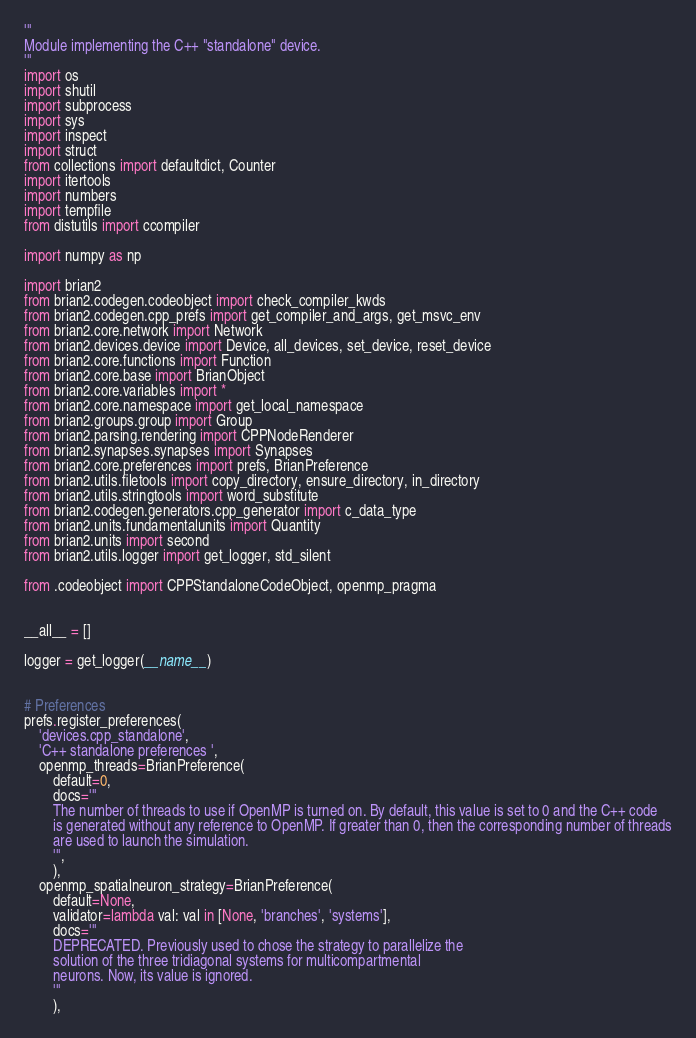<code> <loc_0><loc_0><loc_500><loc_500><_Python_>

'''
Module implementing the C++ "standalone" device.
'''
import os
import shutil
import subprocess
import sys
import inspect
import struct
from collections import defaultdict, Counter
import itertools
import numbers
import tempfile
from distutils import ccompiler

import numpy as np

import brian2
from brian2.codegen.codeobject import check_compiler_kwds
from brian2.codegen.cpp_prefs import get_compiler_and_args, get_msvc_env
from brian2.core.network import Network
from brian2.devices.device import Device, all_devices, set_device, reset_device
from brian2.core.functions import Function
from brian2.core.base import BrianObject
from brian2.core.variables import *
from brian2.core.namespace import get_local_namespace
from brian2.groups.group import Group
from brian2.parsing.rendering import CPPNodeRenderer
from brian2.synapses.synapses import Synapses
from brian2.core.preferences import prefs, BrianPreference
from brian2.utils.filetools import copy_directory, ensure_directory, in_directory
from brian2.utils.stringtools import word_substitute
from brian2.codegen.generators.cpp_generator import c_data_type
from brian2.units.fundamentalunits import Quantity
from brian2.units import second
from brian2.utils.logger import get_logger, std_silent

from .codeobject import CPPStandaloneCodeObject, openmp_pragma


__all__ = []

logger = get_logger(__name__)


# Preferences
prefs.register_preferences(
    'devices.cpp_standalone',
    'C++ standalone preferences ',
    openmp_threads=BrianPreference(
        default=0,
        docs='''
        The number of threads to use if OpenMP is turned on. By default, this value is set to 0 and the C++ code
        is generated without any reference to OpenMP. If greater than 0, then the corresponding number of threads
        are used to launch the simulation.
        ''',
        ),
    openmp_spatialneuron_strategy=BrianPreference(
        default=None,
        validator=lambda val: val in [None, 'branches', 'systems'],
        docs='''
        DEPRECATED. Previously used to chose the strategy to parallelize the
        solution of the three tridiagonal systems for multicompartmental
        neurons. Now, its value is ignored.
        '''
        ),</code> 